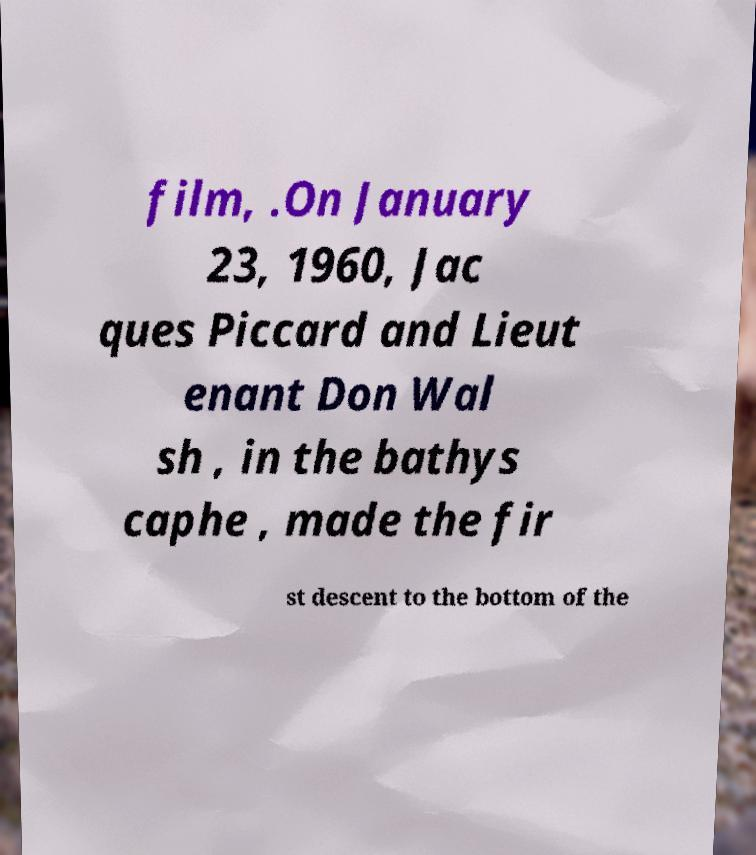Please identify and transcribe the text found in this image. film, .On January 23, 1960, Jac ques Piccard and Lieut enant Don Wal sh , in the bathys caphe , made the fir st descent to the bottom of the 